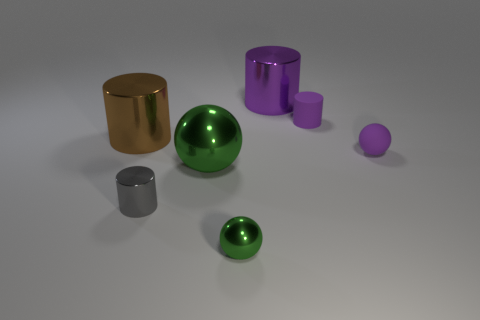Subtract all spheres. How many objects are left? 4 Subtract 2 spheres. How many spheres are left? 1 Subtract all red cylinders. Subtract all brown spheres. How many cylinders are left? 4 Subtract all purple blocks. How many purple spheres are left? 1 Subtract all rubber spheres. Subtract all brown shiny cylinders. How many objects are left? 5 Add 5 big shiny spheres. How many big shiny spheres are left? 6 Add 1 large brown metallic objects. How many large brown metallic objects exist? 2 Add 1 big brown cylinders. How many objects exist? 8 Subtract all gray cylinders. How many cylinders are left? 3 Subtract all green spheres. How many spheres are left? 1 